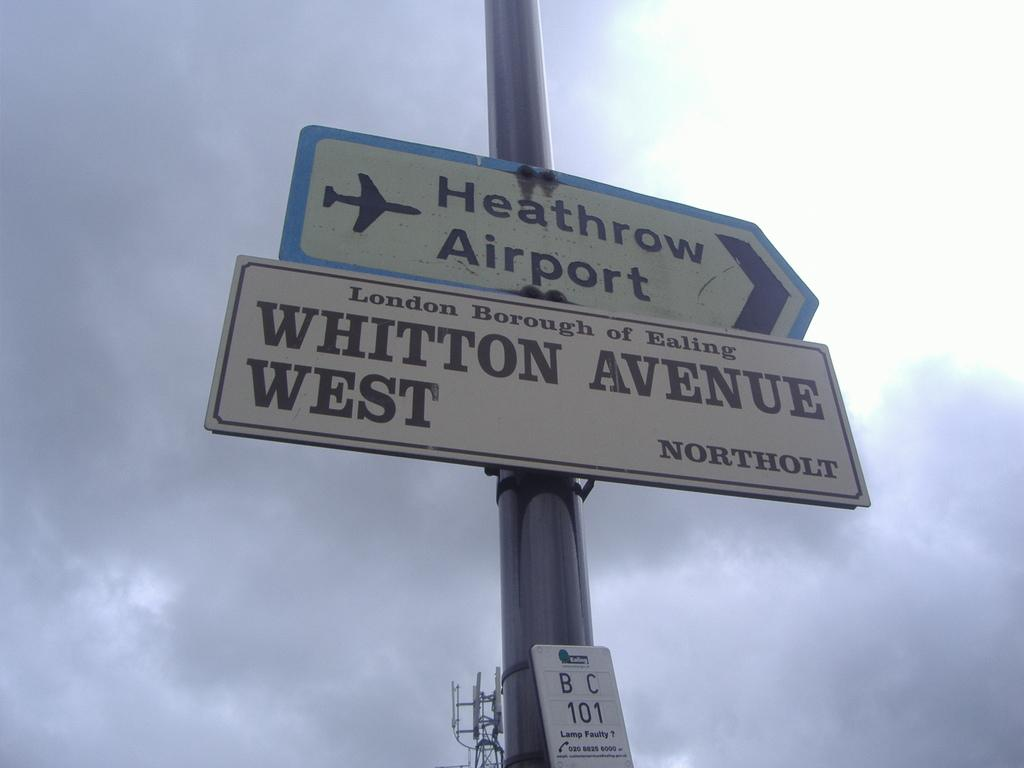What is attached to the pole in the image? There are sign boards attached to the pole in the image. What can be seen in the background of the image? Sky is visible in the image, and clouds are present in the sky. What is located at the bottom of the image? There is a tower at the bottom of the image. What type of grain is growing near the tower in the image? There is no grain present in the image; it features a pole with sign boards, sky with clouds, and a tower. Can you tell me how many lamps are illuminating the tower in the image? There is no lamp present in the image; it only shows a pole with sign boards, sky with clouds, and a tower. 